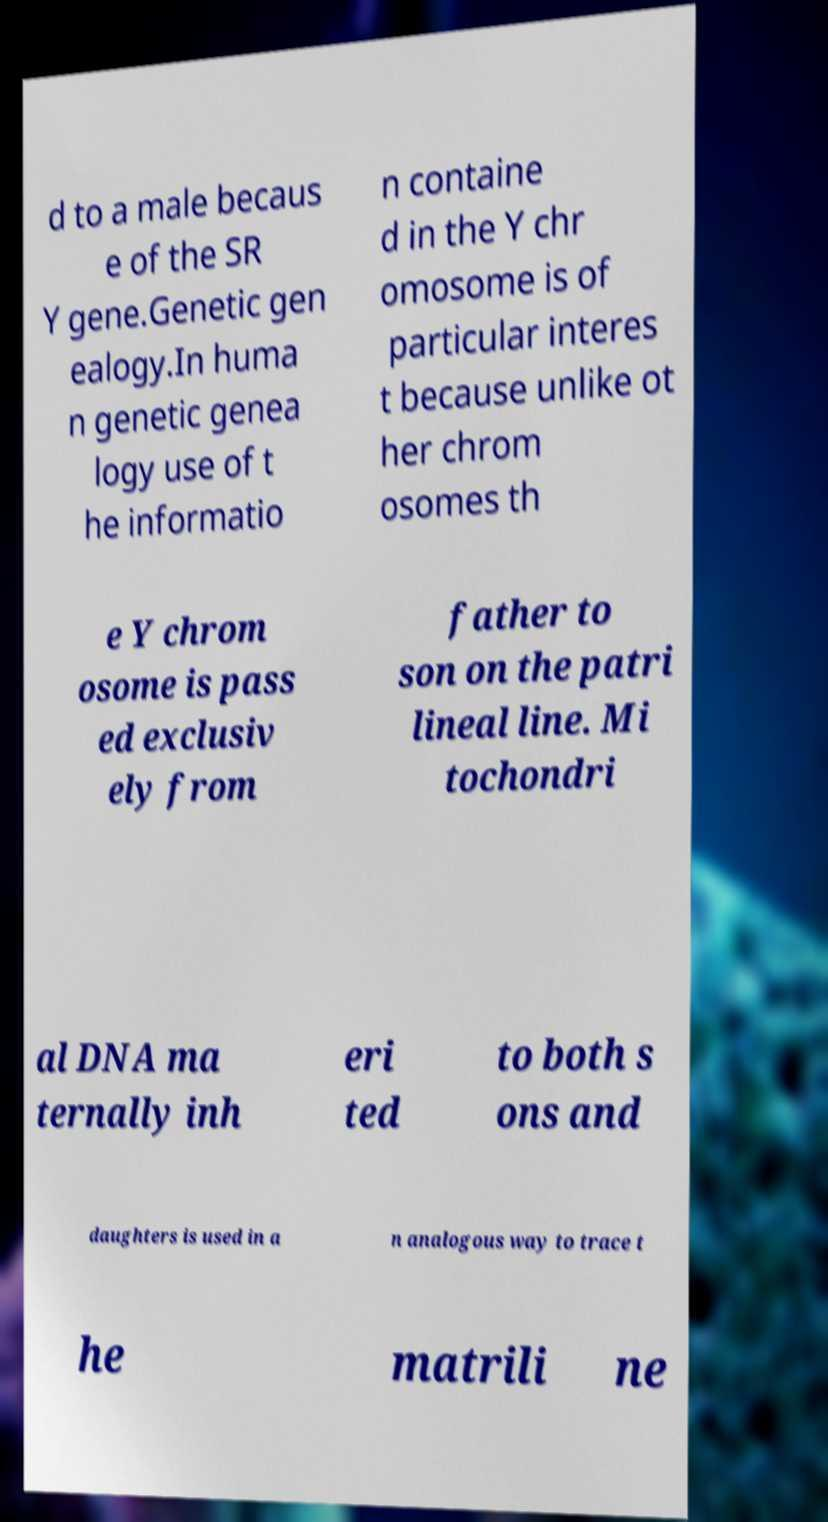Could you extract and type out the text from this image? d to a male becaus e of the SR Y gene.Genetic gen ealogy.In huma n genetic genea logy use of t he informatio n containe d in the Y chr omosome is of particular interes t because unlike ot her chrom osomes th e Y chrom osome is pass ed exclusiv ely from father to son on the patri lineal line. Mi tochondri al DNA ma ternally inh eri ted to both s ons and daughters is used in a n analogous way to trace t he matrili ne 